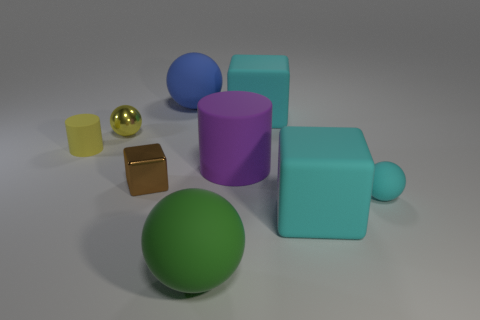Subtract all tiny cyan spheres. How many spheres are left? 3 Subtract all red balls. How many cyan cubes are left? 2 Subtract 1 balls. How many balls are left? 3 Add 1 big cylinders. How many objects exist? 10 Subtract all cyan blocks. How many blocks are left? 1 Subtract 1 yellow balls. How many objects are left? 8 Subtract all cylinders. How many objects are left? 7 Subtract all brown cylinders. Subtract all blue cubes. How many cylinders are left? 2 Subtract all shiny cubes. Subtract all large green rubber objects. How many objects are left? 7 Add 2 big cyan matte objects. How many big cyan matte objects are left? 4 